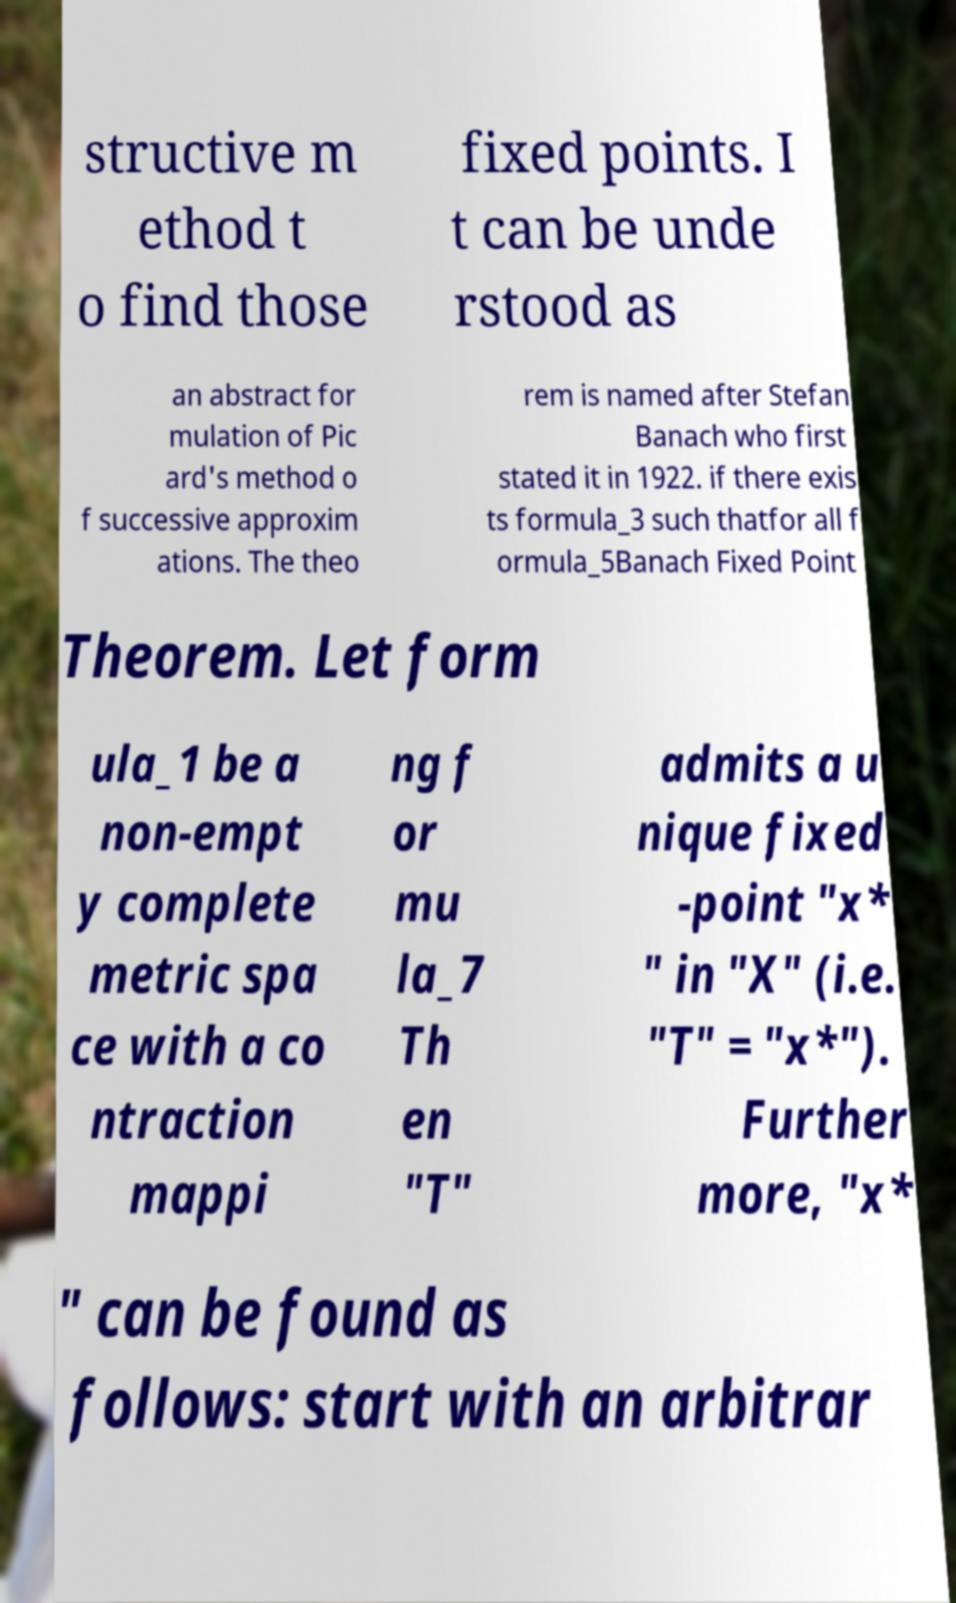I need the written content from this picture converted into text. Can you do that? structive m ethod t o find those fixed points. I t can be unde rstood as an abstract for mulation of Pic ard's method o f successive approxim ations. The theo rem is named after Stefan Banach who first stated it in 1922. if there exis ts formula_3 such thatfor all f ormula_5Banach Fixed Point Theorem. Let form ula_1 be a non-empt y complete metric spa ce with a co ntraction mappi ng f or mu la_7 Th en "T" admits a u nique fixed -point "x* " in "X" (i.e. "T" = "x*"). Further more, "x* " can be found as follows: start with an arbitrar 